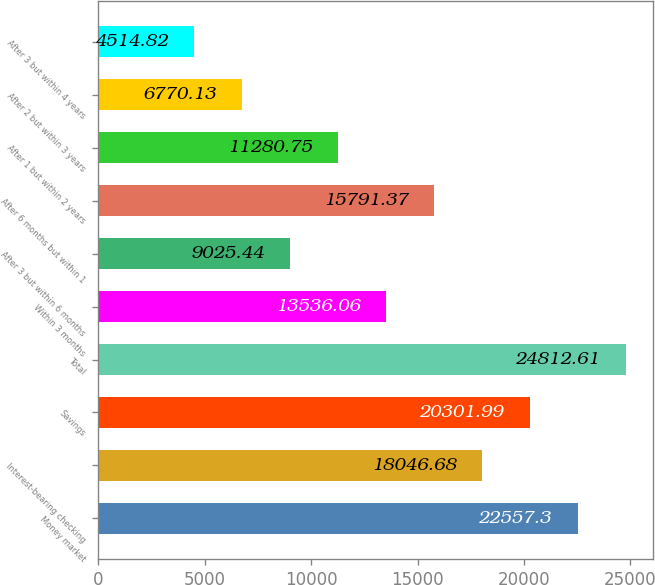<chart> <loc_0><loc_0><loc_500><loc_500><bar_chart><fcel>Money market<fcel>Interest-bearing checking<fcel>Savings<fcel>Total<fcel>Within 3 months<fcel>After 3 but within 6 months<fcel>After 6 months but within 1<fcel>After 1 but within 2 years<fcel>After 2 but within 3 years<fcel>After 3 but within 4 years<nl><fcel>22557.3<fcel>18046.7<fcel>20302<fcel>24812.6<fcel>13536.1<fcel>9025.44<fcel>15791.4<fcel>11280.8<fcel>6770.13<fcel>4514.82<nl></chart> 